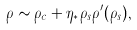Convert formula to latex. <formula><loc_0><loc_0><loc_500><loc_500>\rho \sim \rho _ { c } + \eta _ { * } \rho _ { s } \rho ^ { \prime } ( \rho _ { s } ) ,</formula> 